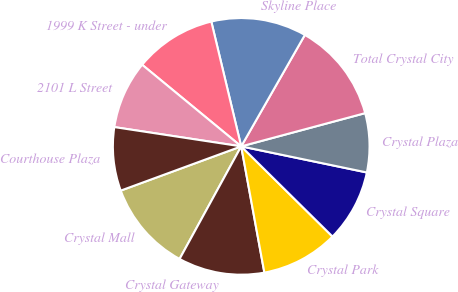Convert chart. <chart><loc_0><loc_0><loc_500><loc_500><pie_chart><fcel>Crystal Mall<fcel>Crystal Gateway<fcel>Crystal Park<fcel>Crystal Square<fcel>Crystal Plaza<fcel>Total Crystal City<fcel>Skyline Place<fcel>1999 K Street - under<fcel>2101 L Street<fcel>Courthouse Plaza<nl><fcel>11.43%<fcel>10.86%<fcel>9.71%<fcel>9.14%<fcel>7.43%<fcel>12.57%<fcel>12.0%<fcel>10.29%<fcel>8.57%<fcel>8.0%<nl></chart> 